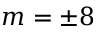Convert formula to latex. <formula><loc_0><loc_0><loc_500><loc_500>m = \pm 8</formula> 